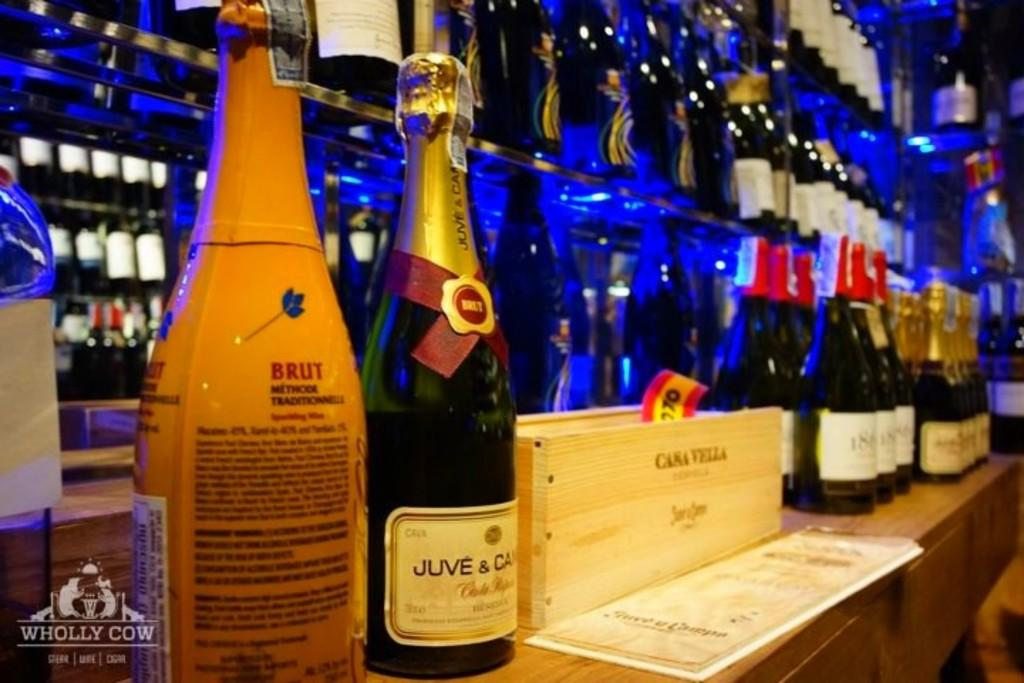<image>
Write a terse but informative summary of the picture. Bottles of champagne displayed at a bar named "Wholly Cow". 